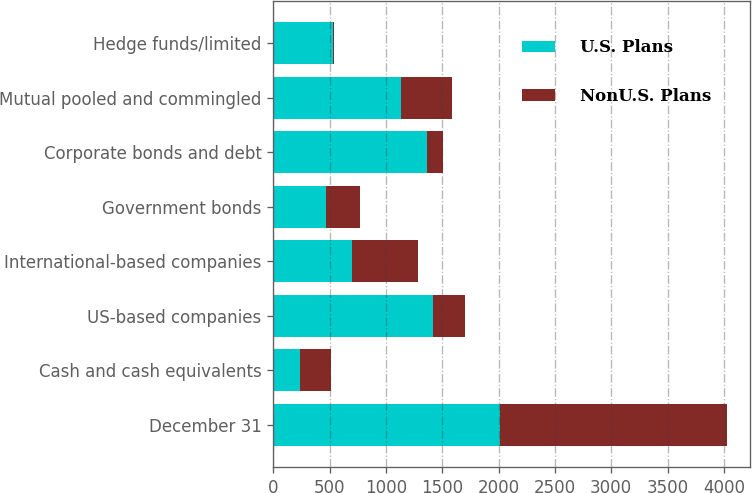Convert chart. <chart><loc_0><loc_0><loc_500><loc_500><stacked_bar_chart><ecel><fcel>December 31<fcel>Cash and cash equivalents<fcel>US-based companies<fcel>International-based companies<fcel>Government bonds<fcel>Corporate bonds and debt<fcel>Mutual pooled and commingled<fcel>Hedge funds/limited<nl><fcel>U.S. Plans<fcel>2013<fcel>240<fcel>1422<fcel>698<fcel>464<fcel>1369<fcel>1134<fcel>526<nl><fcel>NonU.S. Plans<fcel>2013<fcel>274<fcel>280<fcel>586<fcel>304<fcel>137<fcel>453<fcel>17<nl></chart> 